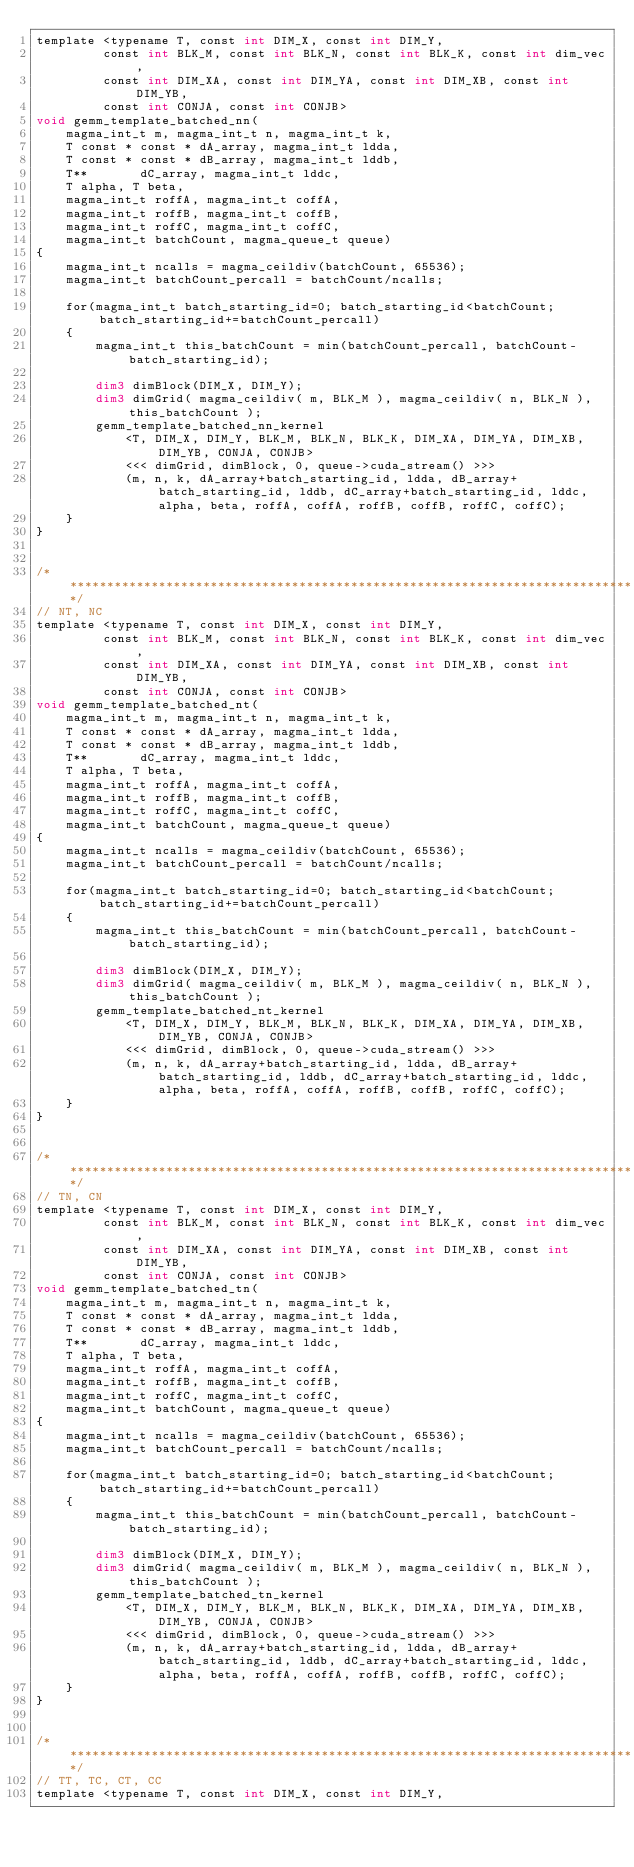<code> <loc_0><loc_0><loc_500><loc_500><_Cuda_>template <typename T, const int DIM_X, const int DIM_Y,
         const int BLK_M, const int BLK_N, const int BLK_K, const int dim_vec,  
         const int DIM_XA, const int DIM_YA, const int DIM_XB, const int DIM_YB, 
         const int CONJA, const int CONJB>
void gemm_template_batched_nn(
    magma_int_t m, magma_int_t n, magma_int_t k,
    T const * const * dA_array, magma_int_t ldda,
    T const * const * dB_array, magma_int_t lddb,
    T**       dC_array, magma_int_t lddc,
    T alpha, T beta, 
    magma_int_t roffA, magma_int_t coffA,
    magma_int_t roffB, magma_int_t coffB,
    magma_int_t roffC, magma_int_t coffC, 
    magma_int_t batchCount, magma_queue_t queue)
{
    magma_int_t ncalls = magma_ceildiv(batchCount, 65536);
    magma_int_t batchCount_percall = batchCount/ncalls;

    for(magma_int_t batch_starting_id=0; batch_starting_id<batchCount; batch_starting_id+=batchCount_percall)
    {
        magma_int_t this_batchCount = min(batchCount_percall, batchCount-batch_starting_id);

        dim3 dimBlock(DIM_X, DIM_Y);
        dim3 dimGrid( magma_ceildiv( m, BLK_M ), magma_ceildiv( n, BLK_N ), this_batchCount );
        gemm_template_batched_nn_kernel
            <T, DIM_X, DIM_Y, BLK_M, BLK_N, BLK_K, DIM_XA, DIM_YA, DIM_XB, DIM_YB, CONJA, CONJB>
            <<< dimGrid, dimBlock, 0, queue->cuda_stream() >>>
            (m, n, k, dA_array+batch_starting_id, ldda, dB_array+batch_starting_id, lddb, dC_array+batch_starting_id, lddc, alpha, beta, roffA, coffA, roffB, coffB, roffC, coffC);
    }
}


/******************************************************************************/
// NT, NC 
template <typename T, const int DIM_X, const int DIM_Y,
         const int BLK_M, const int BLK_N, const int BLK_K, const int dim_vec, 
         const int DIM_XA, const int DIM_YA, const int DIM_XB, const int DIM_YB, 
         const int CONJA, const int CONJB>
void gemm_template_batched_nt(
    magma_int_t m, magma_int_t n, magma_int_t k,
    T const * const * dA_array, magma_int_t ldda,
    T const * const * dB_array, magma_int_t lddb,
    T**       dC_array, magma_int_t lddc,
    T alpha, T beta,
    magma_int_t roffA, magma_int_t coffA,
    magma_int_t roffB, magma_int_t coffB,
    magma_int_t roffC, magma_int_t coffC, 
    magma_int_t batchCount, magma_queue_t queue)
{
    magma_int_t ncalls = magma_ceildiv(batchCount, 65536);
    magma_int_t batchCount_percall = batchCount/ncalls;

    for(magma_int_t batch_starting_id=0; batch_starting_id<batchCount; batch_starting_id+=batchCount_percall)
    {
        magma_int_t this_batchCount = min(batchCount_percall, batchCount-batch_starting_id);

        dim3 dimBlock(DIM_X, DIM_Y);
        dim3 dimGrid( magma_ceildiv( m, BLK_M ), magma_ceildiv( n, BLK_N ), this_batchCount );
        gemm_template_batched_nt_kernel
            <T, DIM_X, DIM_Y, BLK_M, BLK_N, BLK_K, DIM_XA, DIM_YA, DIM_XB, DIM_YB, CONJA, CONJB>
            <<< dimGrid, dimBlock, 0, queue->cuda_stream() >>>
            (m, n, k, dA_array+batch_starting_id, ldda, dB_array+batch_starting_id, lddb, dC_array+batch_starting_id, lddc, alpha, beta, roffA, coffA, roffB, coffB, roffC, coffC);
    }
}


/******************************************************************************/
// TN, CN 
template <typename T, const int DIM_X, const int DIM_Y,
         const int BLK_M, const int BLK_N, const int BLK_K, const int dim_vec,
         const int DIM_XA, const int DIM_YA, const int DIM_XB, const int DIM_YB, 
         const int CONJA, const int CONJB>
void gemm_template_batched_tn(
    magma_int_t m, magma_int_t n, magma_int_t k,
    T const * const * dA_array, magma_int_t ldda,
    T const * const * dB_array, magma_int_t lddb,
    T**       dC_array, magma_int_t lddc,
    T alpha, T beta, 
    magma_int_t roffA, magma_int_t coffA,
    magma_int_t roffB, magma_int_t coffB,
    magma_int_t roffC, magma_int_t coffC, 
    magma_int_t batchCount, magma_queue_t queue)
{
    magma_int_t ncalls = magma_ceildiv(batchCount, 65536);
    magma_int_t batchCount_percall = batchCount/ncalls;

    for(magma_int_t batch_starting_id=0; batch_starting_id<batchCount; batch_starting_id+=batchCount_percall)
    {
        magma_int_t this_batchCount = min(batchCount_percall, batchCount-batch_starting_id);

        dim3 dimBlock(DIM_X, DIM_Y);
        dim3 dimGrid( magma_ceildiv( m, BLK_M ), magma_ceildiv( n, BLK_N ), this_batchCount );
        gemm_template_batched_tn_kernel
            <T, DIM_X, DIM_Y, BLK_M, BLK_N, BLK_K, DIM_XA, DIM_YA, DIM_XB, DIM_YB, CONJA, CONJB>
            <<< dimGrid, dimBlock, 0, queue->cuda_stream() >>>
            (m, n, k, dA_array+batch_starting_id, ldda, dB_array+batch_starting_id, lddb, dC_array+batch_starting_id, lddc, alpha, beta, roffA, coffA, roffB, coffB, roffC, coffC);
    }
}


/******************************************************************************/
// TT, TC, CT, CC
template <typename T, const int DIM_X, const int DIM_Y,</code> 